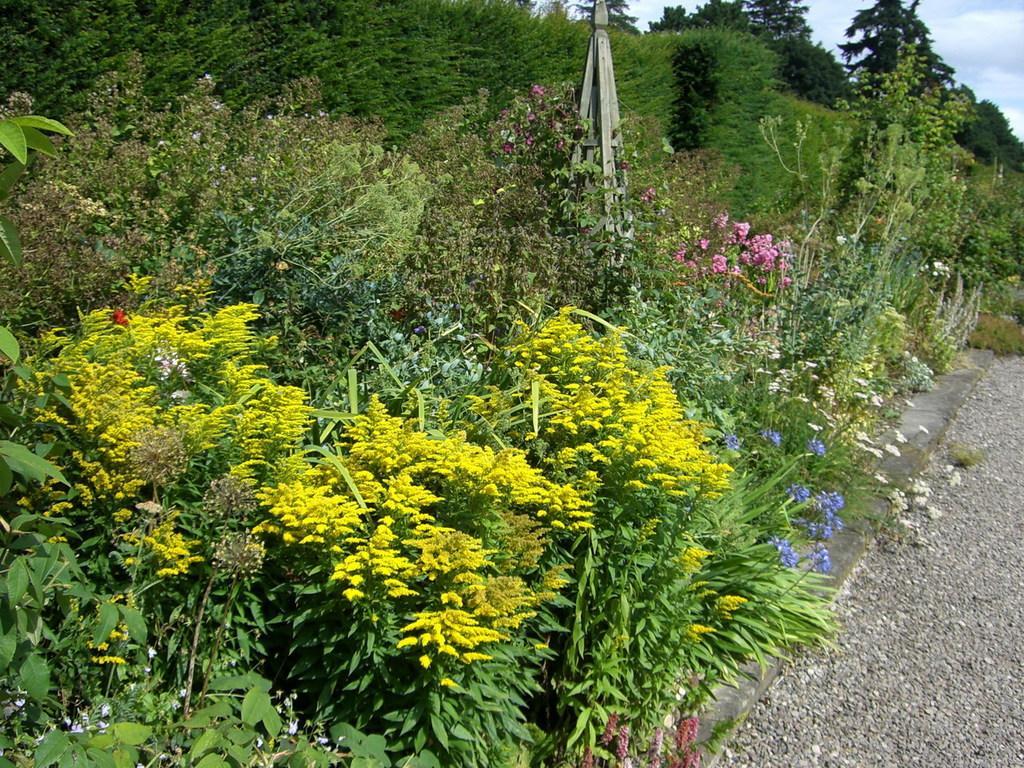Please provide a concise description of this image. In the left side these are the plants, in the middle there are few flower plants. 